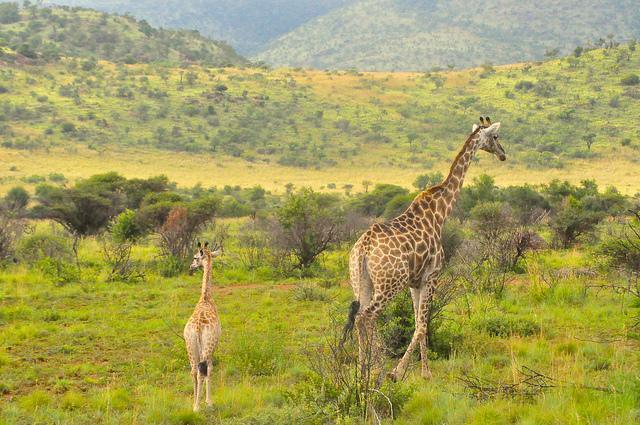How many giraffes can be seen?
Give a very brief answer. 2. 